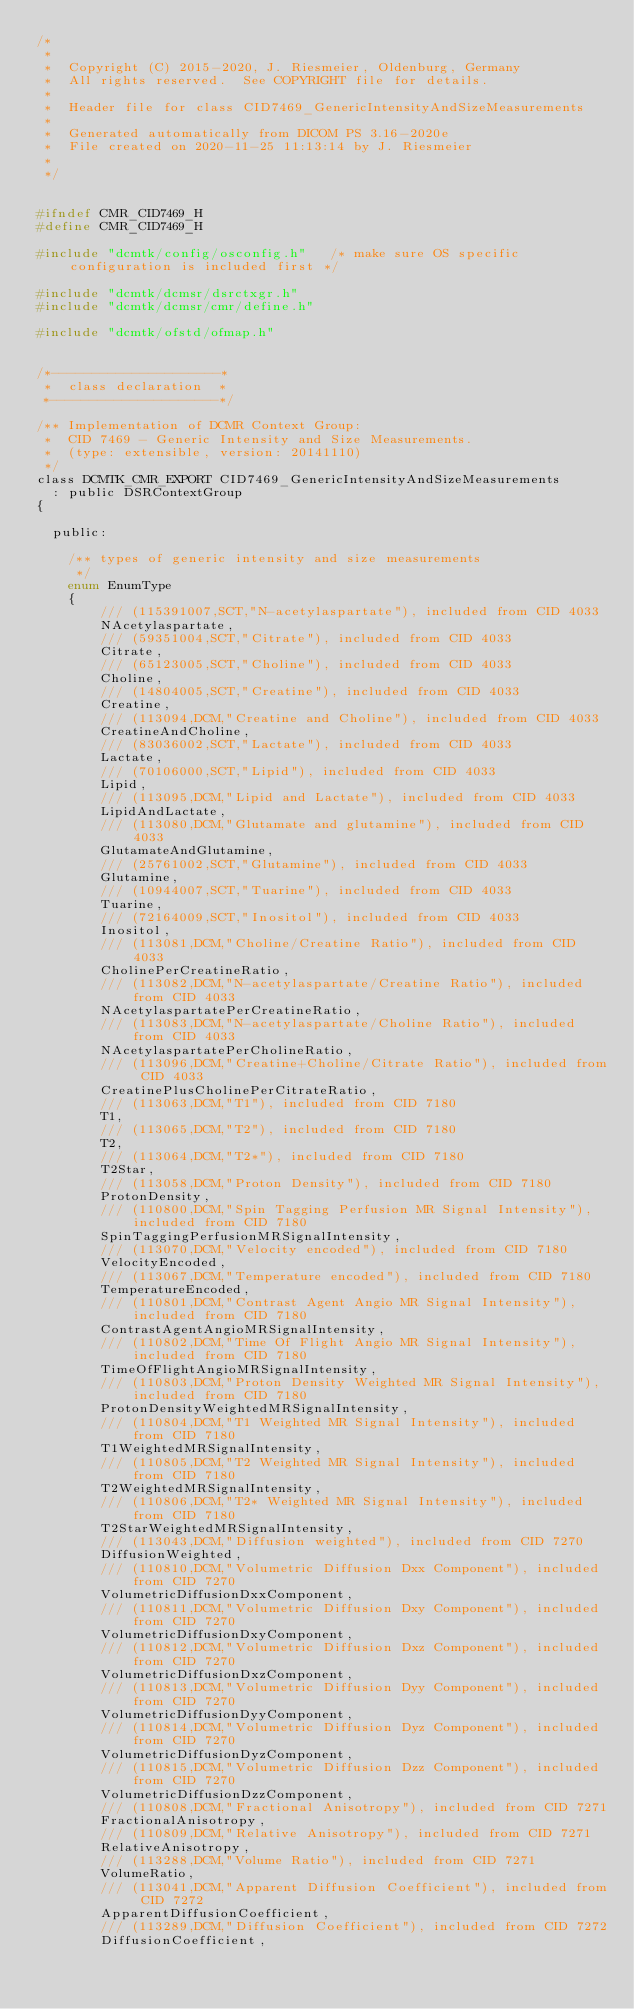<code> <loc_0><loc_0><loc_500><loc_500><_C_>/*
 *
 *  Copyright (C) 2015-2020, J. Riesmeier, Oldenburg, Germany
 *  All rights reserved.  See COPYRIGHT file for details.
 *
 *  Header file for class CID7469_GenericIntensityAndSizeMeasurements
 *
 *  Generated automatically from DICOM PS 3.16-2020e
 *  File created on 2020-11-25 11:13:14 by J. Riesmeier
 *
 */


#ifndef CMR_CID7469_H
#define CMR_CID7469_H

#include "dcmtk/config/osconfig.h"   /* make sure OS specific configuration is included first */

#include "dcmtk/dcmsr/dsrctxgr.h"
#include "dcmtk/dcmsr/cmr/define.h"

#include "dcmtk/ofstd/ofmap.h"


/*---------------------*
 *  class declaration  *
 *---------------------*/

/** Implementation of DCMR Context Group:
 *  CID 7469 - Generic Intensity and Size Measurements.
 *  (type: extensible, version: 20141110)
 */
class DCMTK_CMR_EXPORT CID7469_GenericIntensityAndSizeMeasurements
  : public DSRContextGroup
{

  public:

    /** types of generic intensity and size measurements
     */
    enum EnumType
    {
        /// (115391007,SCT,"N-acetylaspartate"), included from CID 4033
        NAcetylaspartate,
        /// (59351004,SCT,"Citrate"), included from CID 4033
        Citrate,
        /// (65123005,SCT,"Choline"), included from CID 4033
        Choline,
        /// (14804005,SCT,"Creatine"), included from CID 4033
        Creatine,
        /// (113094,DCM,"Creatine and Choline"), included from CID 4033
        CreatineAndCholine,
        /// (83036002,SCT,"Lactate"), included from CID 4033
        Lactate,
        /// (70106000,SCT,"Lipid"), included from CID 4033
        Lipid,
        /// (113095,DCM,"Lipid and Lactate"), included from CID 4033
        LipidAndLactate,
        /// (113080,DCM,"Glutamate and glutamine"), included from CID 4033
        GlutamateAndGlutamine,
        /// (25761002,SCT,"Glutamine"), included from CID 4033
        Glutamine,
        /// (10944007,SCT,"Tuarine"), included from CID 4033
        Tuarine,
        /// (72164009,SCT,"Inositol"), included from CID 4033
        Inositol,
        /// (113081,DCM,"Choline/Creatine Ratio"), included from CID 4033
        CholinePerCreatineRatio,
        /// (113082,DCM,"N-acetylaspartate/Creatine Ratio"), included from CID 4033
        NAcetylaspartatePerCreatineRatio,
        /// (113083,DCM,"N-acetylaspartate/Choline Ratio"), included from CID 4033
        NAcetylaspartatePerCholineRatio,
        /// (113096,DCM,"Creatine+Choline/Citrate Ratio"), included from CID 4033
        CreatinePlusCholinePerCitrateRatio,
        /// (113063,DCM,"T1"), included from CID 7180
        T1,
        /// (113065,DCM,"T2"), included from CID 7180
        T2,
        /// (113064,DCM,"T2*"), included from CID 7180
        T2Star,
        /// (113058,DCM,"Proton Density"), included from CID 7180
        ProtonDensity,
        /// (110800,DCM,"Spin Tagging Perfusion MR Signal Intensity"), included from CID 7180
        SpinTaggingPerfusionMRSignalIntensity,
        /// (113070,DCM,"Velocity encoded"), included from CID 7180
        VelocityEncoded,
        /// (113067,DCM,"Temperature encoded"), included from CID 7180
        TemperatureEncoded,
        /// (110801,DCM,"Contrast Agent Angio MR Signal Intensity"), included from CID 7180
        ContrastAgentAngioMRSignalIntensity,
        /// (110802,DCM,"Time Of Flight Angio MR Signal Intensity"), included from CID 7180
        TimeOfFlightAngioMRSignalIntensity,
        /// (110803,DCM,"Proton Density Weighted MR Signal Intensity"), included from CID 7180
        ProtonDensityWeightedMRSignalIntensity,
        /// (110804,DCM,"T1 Weighted MR Signal Intensity"), included from CID 7180
        T1WeightedMRSignalIntensity,
        /// (110805,DCM,"T2 Weighted MR Signal Intensity"), included from CID 7180
        T2WeightedMRSignalIntensity,
        /// (110806,DCM,"T2* Weighted MR Signal Intensity"), included from CID 7180
        T2StarWeightedMRSignalIntensity,
        /// (113043,DCM,"Diffusion weighted"), included from CID 7270
        DiffusionWeighted,
        /// (110810,DCM,"Volumetric Diffusion Dxx Component"), included from CID 7270
        VolumetricDiffusionDxxComponent,
        /// (110811,DCM,"Volumetric Diffusion Dxy Component"), included from CID 7270
        VolumetricDiffusionDxyComponent,
        /// (110812,DCM,"Volumetric Diffusion Dxz Component"), included from CID 7270
        VolumetricDiffusionDxzComponent,
        /// (110813,DCM,"Volumetric Diffusion Dyy Component"), included from CID 7270
        VolumetricDiffusionDyyComponent,
        /// (110814,DCM,"Volumetric Diffusion Dyz Component"), included from CID 7270
        VolumetricDiffusionDyzComponent,
        /// (110815,DCM,"Volumetric Diffusion Dzz Component"), included from CID 7270
        VolumetricDiffusionDzzComponent,
        /// (110808,DCM,"Fractional Anisotropy"), included from CID 7271
        FractionalAnisotropy,
        /// (110809,DCM,"Relative Anisotropy"), included from CID 7271
        RelativeAnisotropy,
        /// (113288,DCM,"Volume Ratio"), included from CID 7271
        VolumeRatio,
        /// (113041,DCM,"Apparent Diffusion Coefficient"), included from CID 7272
        ApparentDiffusionCoefficient,
        /// (113289,DCM,"Diffusion Coefficient"), included from CID 7272
        DiffusionCoefficient,</code> 